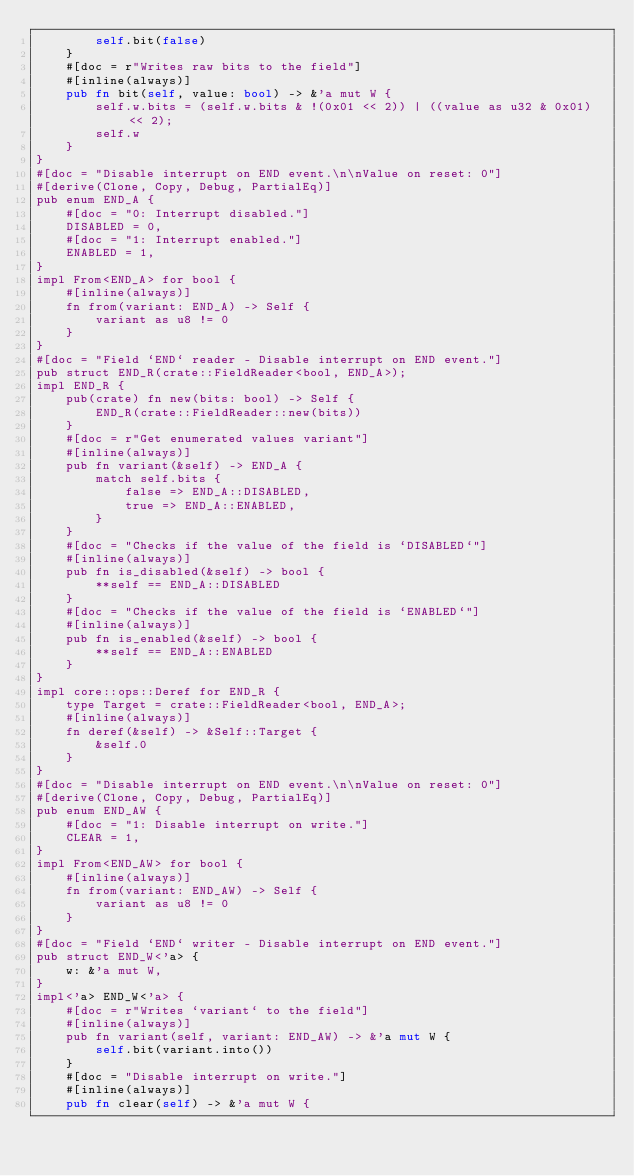<code> <loc_0><loc_0><loc_500><loc_500><_Rust_>        self.bit(false)
    }
    #[doc = r"Writes raw bits to the field"]
    #[inline(always)]
    pub fn bit(self, value: bool) -> &'a mut W {
        self.w.bits = (self.w.bits & !(0x01 << 2)) | ((value as u32 & 0x01) << 2);
        self.w
    }
}
#[doc = "Disable interrupt on END event.\n\nValue on reset: 0"]
#[derive(Clone, Copy, Debug, PartialEq)]
pub enum END_A {
    #[doc = "0: Interrupt disabled."]
    DISABLED = 0,
    #[doc = "1: Interrupt enabled."]
    ENABLED = 1,
}
impl From<END_A> for bool {
    #[inline(always)]
    fn from(variant: END_A) -> Self {
        variant as u8 != 0
    }
}
#[doc = "Field `END` reader - Disable interrupt on END event."]
pub struct END_R(crate::FieldReader<bool, END_A>);
impl END_R {
    pub(crate) fn new(bits: bool) -> Self {
        END_R(crate::FieldReader::new(bits))
    }
    #[doc = r"Get enumerated values variant"]
    #[inline(always)]
    pub fn variant(&self) -> END_A {
        match self.bits {
            false => END_A::DISABLED,
            true => END_A::ENABLED,
        }
    }
    #[doc = "Checks if the value of the field is `DISABLED`"]
    #[inline(always)]
    pub fn is_disabled(&self) -> bool {
        **self == END_A::DISABLED
    }
    #[doc = "Checks if the value of the field is `ENABLED`"]
    #[inline(always)]
    pub fn is_enabled(&self) -> bool {
        **self == END_A::ENABLED
    }
}
impl core::ops::Deref for END_R {
    type Target = crate::FieldReader<bool, END_A>;
    #[inline(always)]
    fn deref(&self) -> &Self::Target {
        &self.0
    }
}
#[doc = "Disable interrupt on END event.\n\nValue on reset: 0"]
#[derive(Clone, Copy, Debug, PartialEq)]
pub enum END_AW {
    #[doc = "1: Disable interrupt on write."]
    CLEAR = 1,
}
impl From<END_AW> for bool {
    #[inline(always)]
    fn from(variant: END_AW) -> Self {
        variant as u8 != 0
    }
}
#[doc = "Field `END` writer - Disable interrupt on END event."]
pub struct END_W<'a> {
    w: &'a mut W,
}
impl<'a> END_W<'a> {
    #[doc = r"Writes `variant` to the field"]
    #[inline(always)]
    pub fn variant(self, variant: END_AW) -> &'a mut W {
        self.bit(variant.into())
    }
    #[doc = "Disable interrupt on write."]
    #[inline(always)]
    pub fn clear(self) -> &'a mut W {</code> 